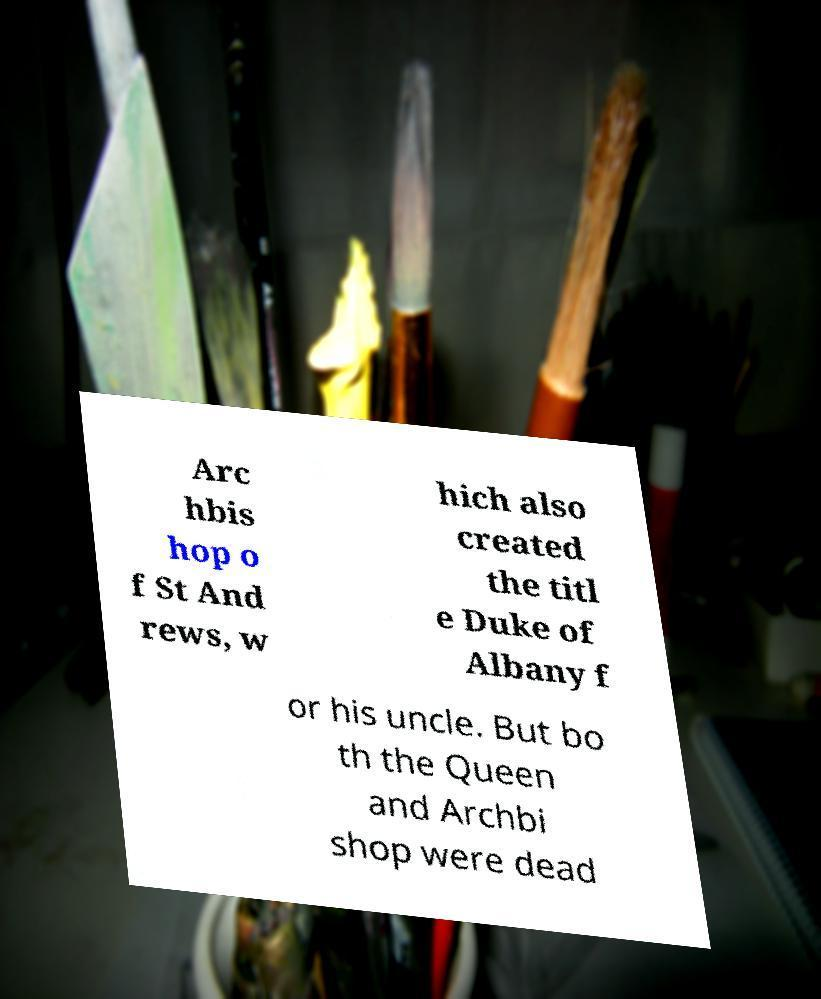Please identify and transcribe the text found in this image. Arc hbis hop o f St And rews, w hich also created the titl e Duke of Albany f or his uncle. But bo th the Queen and Archbi shop were dead 